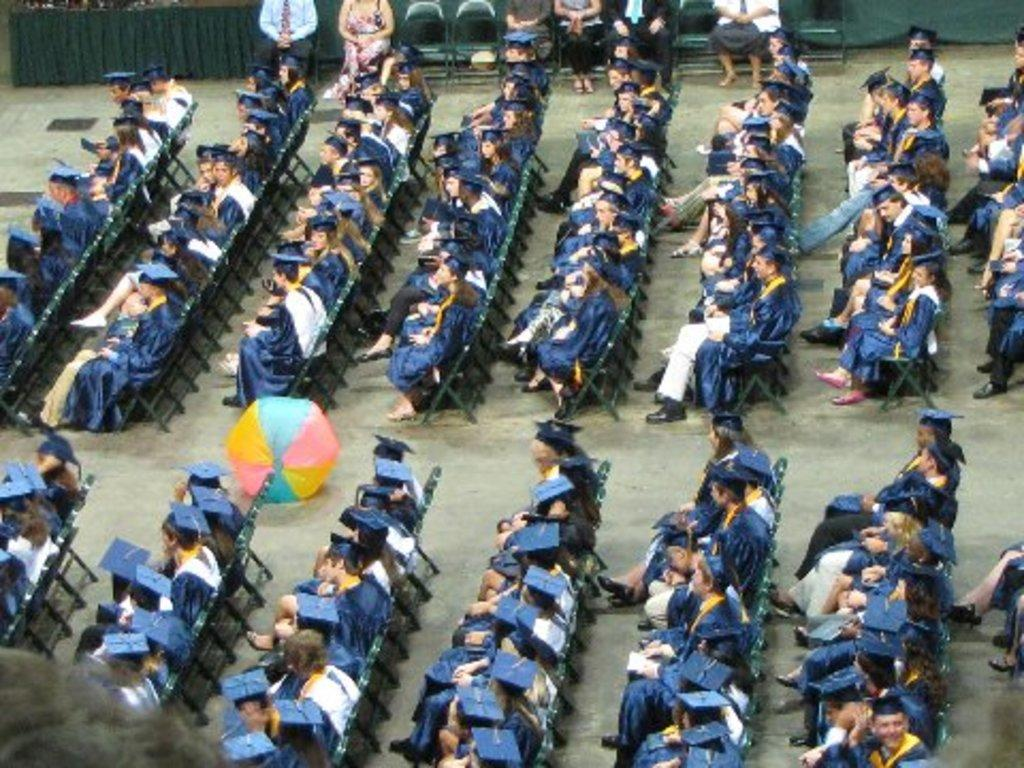Who or what can be seen in the image? There are persons in the image. What are the persons doing in the image? The persons are sitting on chairs. Where are the chairs located in the image? The chairs are on the floor. What news is being taught by the persons in the image? There is no news or teaching activity depicted in the image; the persons are simply sitting on chairs. 